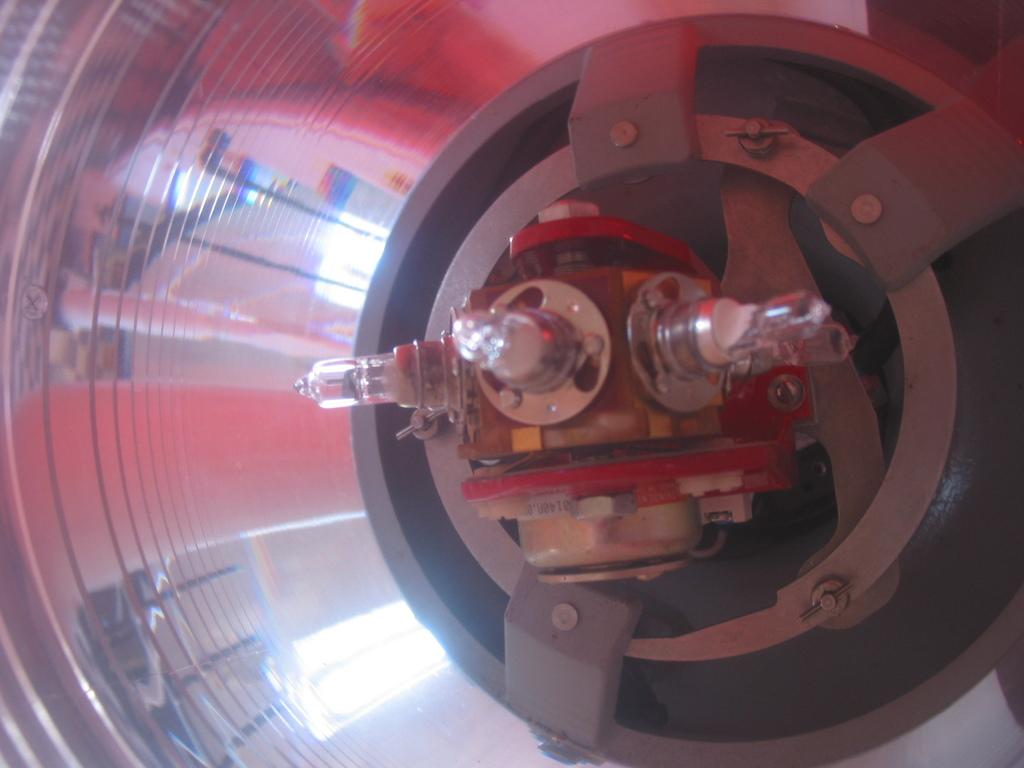What type of object is located on the right side of the image? There is an electronic gadget in the image, and it is on the right side. Can you describe the electronic gadget in more detail? Unfortunately, the provided facts do not give more details about the electronic gadget. What can be seen in the middle of the image? There are three small lights in the middle of the image. Where is the sink located in the image? There is no sink present in the image. What type of pencil can be seen next to the electronic gadget? There is no pencil present in the image. 